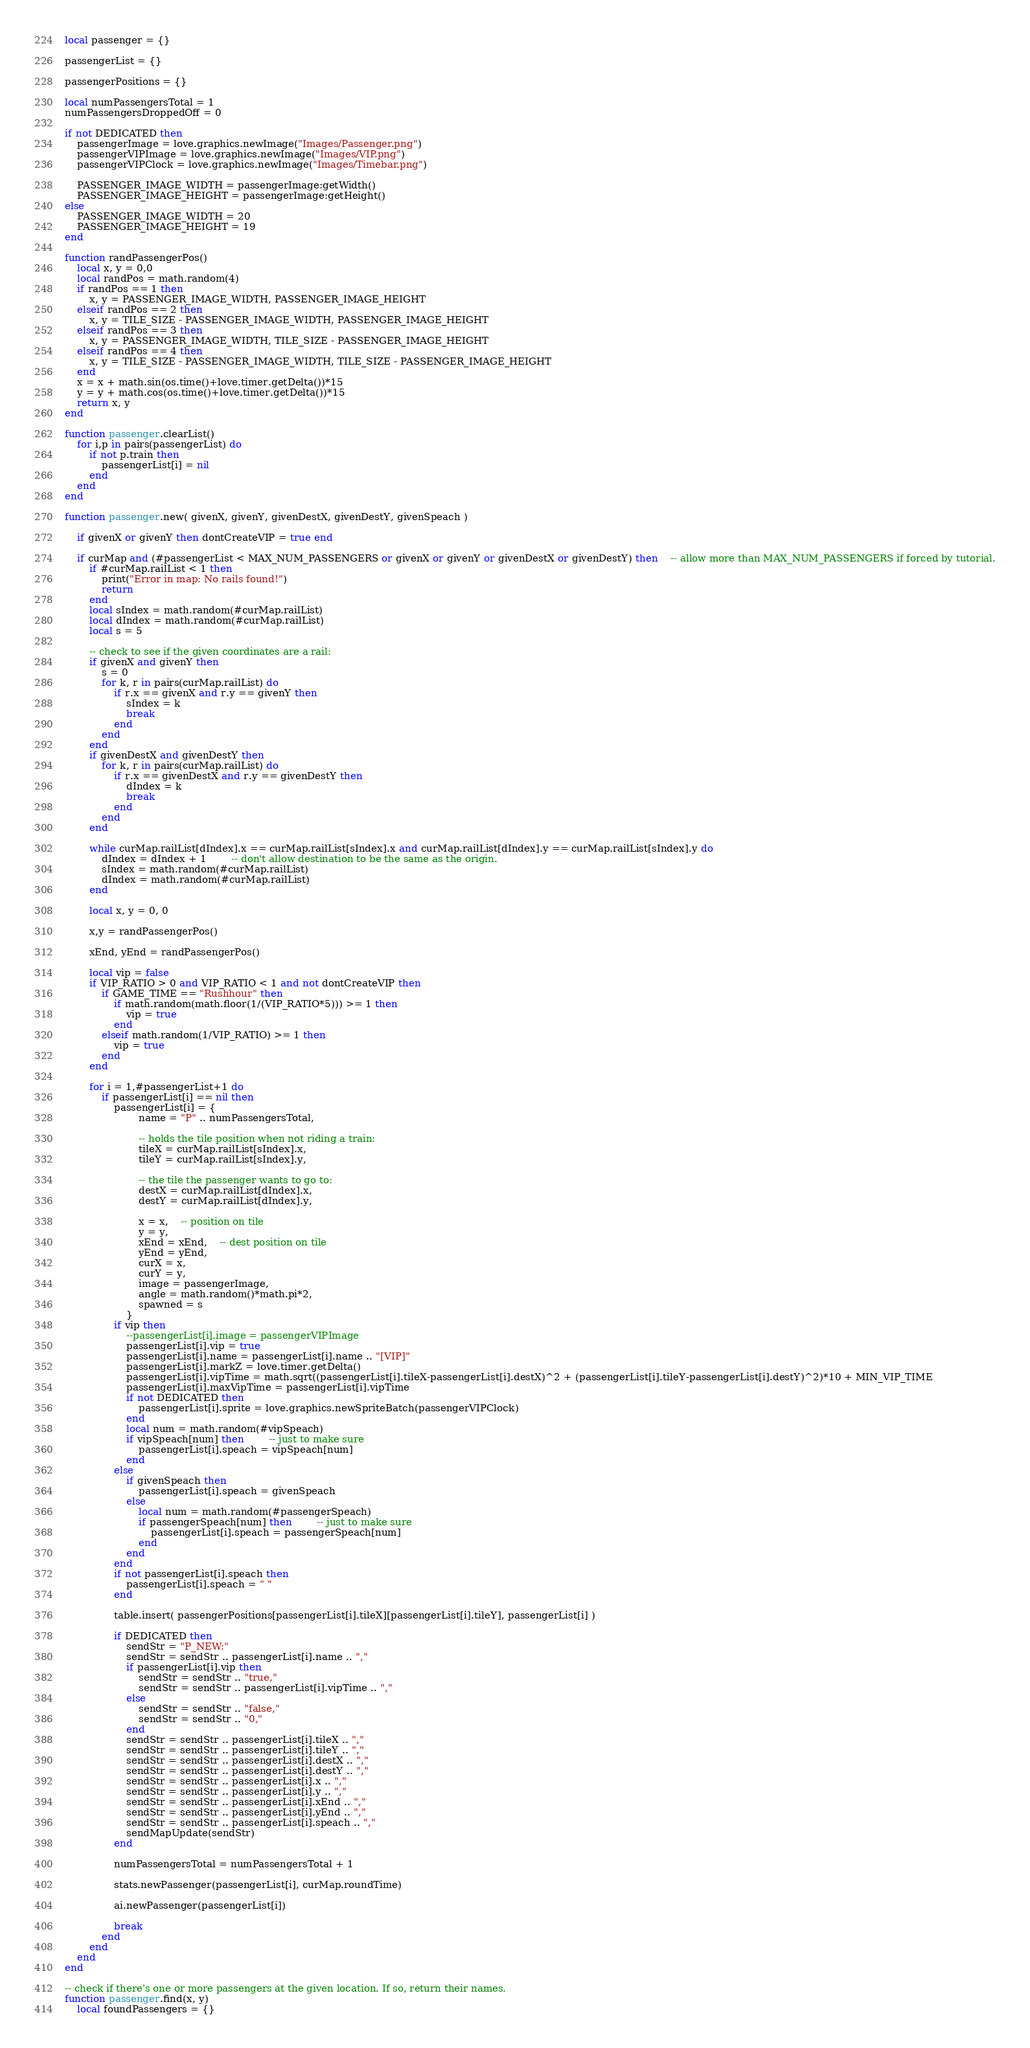<code> <loc_0><loc_0><loc_500><loc_500><_Lua_>local passenger = {}

passengerList = {}

passengerPositions = {}

local numPassengersTotal = 1
numPassengersDroppedOff = 0

if not DEDICATED then
	passengerImage = love.graphics.newImage("Images/Passenger.png")
	passengerVIPImage = love.graphics.newImage("Images/VIP.png")
	passengerVIPClock = love.graphics.newImage("Images/Timebar.png")
	
	PASSENGER_IMAGE_WIDTH = passengerImage:getWidth()
	PASSENGER_IMAGE_HEIGHT = passengerImage:getHeight()
else
	PASSENGER_IMAGE_WIDTH = 20
	PASSENGER_IMAGE_HEIGHT = 19
end

function randPassengerPos()
	local x, y = 0,0
	local randPos = math.random(4)
	if randPos == 1 then
		x, y = PASSENGER_IMAGE_WIDTH, PASSENGER_IMAGE_HEIGHT
	elseif randPos == 2 then
		x, y = TILE_SIZE - PASSENGER_IMAGE_WIDTH, PASSENGER_IMAGE_HEIGHT
	elseif randPos == 3 then
		x, y = PASSENGER_IMAGE_WIDTH, TILE_SIZE - PASSENGER_IMAGE_HEIGHT
	elseif randPos == 4 then
		x, y = TILE_SIZE - PASSENGER_IMAGE_WIDTH, TILE_SIZE - PASSENGER_IMAGE_HEIGHT
	end
	x = x + math.sin(os.time()+love.timer.getDelta())*15
	y = y + math.cos(os.time()+love.timer.getDelta())*15
	return x, y
end

function passenger.clearList()
	for i,p in pairs(passengerList) do
		if not p.train then
			passengerList[i] = nil
		end
	end
end

function passenger.new( givenX, givenY, givenDestX, givenDestY, givenSpeach )
	
	if givenX or givenY then dontCreateVIP = true end
	
	if curMap and (#passengerList < MAX_NUM_PASSENGERS or givenX or givenY or givenDestX or givenDestY) then	-- allow more than MAX_NUM_PASSENGERS if forced by tutorial.
		if #curMap.railList < 1 then
			print("Error in map: No rails found!")
			return
		end
		local sIndex = math.random(#curMap.railList)
		local dIndex = math.random(#curMap.railList)
		local s = 5
		
		-- check to see if the given coordinates are a rail:
		if givenX and givenY then
			s = 0
			for k, r in pairs(curMap.railList) do
				if r.x == givenX and r.y == givenY then
					sIndex = k
					break
				end
			end
		end
		if givenDestX and givenDestY then
			for k, r in pairs(curMap.railList) do
				if r.x == givenDestX and r.y == givenDestY then
					dIndex = k
					break
				end
			end
		end
		
		while curMap.railList[dIndex].x == curMap.railList[sIndex].x and curMap.railList[dIndex].y == curMap.railList[sIndex].y do
			dIndex = dIndex + 1		-- don't allow destination to be the same as the origin.
			sIndex = math.random(#curMap.railList)
			dIndex = math.random(#curMap.railList)
		end
		
		local x, y = 0, 0

		x,y = randPassengerPos()

		xEnd, yEnd = randPassengerPos()
		
		local vip = false
		if VIP_RATIO > 0 and VIP_RATIO < 1 and not dontCreateVIP then
			if GAME_TIME == "Rushhour" then
				if math.random(math.floor(1/(VIP_RATIO*5))) >= 1 then
					vip = true
				end
			elseif math.random(1/VIP_RATIO) >= 1 then
				vip = true
			end
		end
		
		for i = 1,#passengerList+1 do
			if passengerList[i] == nil then
				passengerList[i] = {
						name = "P" .. numPassengersTotal,
						
						-- holds the tile position when not riding a train:
						tileX = curMap.railList[sIndex].x,
						tileY = curMap.railList[sIndex].y,
						
						-- the tile the passenger wants to go to:
						destX = curMap.railList[dIndex].x,
						destY = curMap.railList[dIndex].y,
						
						x = x,	-- position on tile
						y = y,
						xEnd = xEnd,	-- dest position on tile
						yEnd = yEnd,
						curX = x,
						curY = y,
						image = passengerImage,
						angle = math.random()*math.pi*2,
						spawned = s
					}
				if vip then
					--passengerList[i].image = passengerVIPImage
					passengerList[i].vip = true
					passengerList[i].name = passengerList[i].name .. "[VIP]"
					passengerList[i].markZ = love.timer.getDelta()
					passengerList[i].vipTime = math.sqrt((passengerList[i].tileX-passengerList[i].destX)^2 + (passengerList[i].tileY-passengerList[i].destY)^2)*10 + MIN_VIP_TIME
					passengerList[i].maxVipTime = passengerList[i].vipTime
					if not DEDICATED then
						passengerList[i].sprite = love.graphics.newSpriteBatch(passengerVIPClock)
					end
					local num = math.random(#vipSpeach)
					if vipSpeach[num] then		-- just to make sure
						passengerList[i].speach = vipSpeach[num]
					end
				else
					if givenSpeach then
						passengerList[i].speach = givenSpeach
					else
						local num = math.random(#passengerSpeach)
						if passengerSpeach[num] then		-- just to make sure
							passengerList[i].speach = passengerSpeach[num]
						end
					end
				end
				if not passengerList[i].speach then
					passengerList[i].speach = " "
				end
				
				table.insert( passengerPositions[passengerList[i].tileX][passengerList[i].tileY], passengerList[i] )
				
				if DEDICATED then
					sendStr = "P_NEW:"
					sendStr = sendStr .. passengerList[i].name .. ","
					if passengerList[i].vip then
						sendStr = sendStr .. "true,"
						sendStr = sendStr .. passengerList[i].vipTime .. ","
					else
						sendStr = sendStr .. "false,"
						sendStr = sendStr .. "0,"
					end
					sendStr = sendStr .. passengerList[i].tileX .. ","
					sendStr = sendStr .. passengerList[i].tileY .. ","
					sendStr = sendStr .. passengerList[i].destX .. ","
					sendStr = sendStr .. passengerList[i].destY .. ","
					sendStr = sendStr .. passengerList[i].x .. ","
					sendStr = sendStr .. passengerList[i].y .. ","
					sendStr = sendStr .. passengerList[i].xEnd .. ","
					sendStr = sendStr .. passengerList[i].yEnd .. ","
					sendStr = sendStr .. passengerList[i].speach .. ","
					sendMapUpdate(sendStr)
				end
				
				numPassengersTotal = numPassengersTotal + 1
				
				stats.newPassenger(passengerList[i], curMap.roundTime)
				
				ai.newPassenger(passengerList[i])
				
				break
			end
		end
	end
end

-- check if there's one or more passengers at the given location. If so, return their names.
function passenger.find(x, y)
	local foundPassengers = {}</code> 